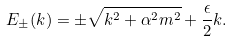Convert formula to latex. <formula><loc_0><loc_0><loc_500><loc_500>E _ { \pm } ( k ) = \pm \sqrt { k ^ { 2 } + \alpha ^ { 2 } m ^ { 2 } } + \frac { \epsilon } { 2 } k .</formula> 